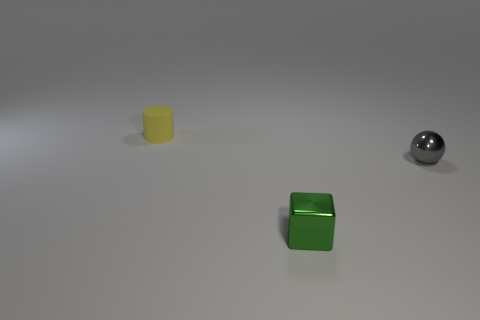There is a thing that is both behind the small green thing and left of the shiny ball; how big is it?
Your answer should be very brief. Small. What number of other objects are the same shape as the small yellow object?
Offer a very short reply. 0. What number of blocks are yellow matte objects or gray objects?
Your answer should be very brief. 0. There is a small metal object behind the metallic thing that is to the left of the tiny metal ball; is there a block that is on the right side of it?
Provide a succinct answer. No. What number of green things are metallic spheres or small rubber cylinders?
Offer a terse response. 0. What is the material of the object behind the small shiny object right of the cube?
Your response must be concise. Rubber. Does the green thing have the same shape as the yellow object?
Ensure brevity in your answer.  No. There is a rubber object that is the same size as the green block; what is its color?
Keep it short and to the point. Yellow. Are there any big balls of the same color as the small matte cylinder?
Provide a succinct answer. No. Is there a metal object?
Your answer should be compact. Yes. 